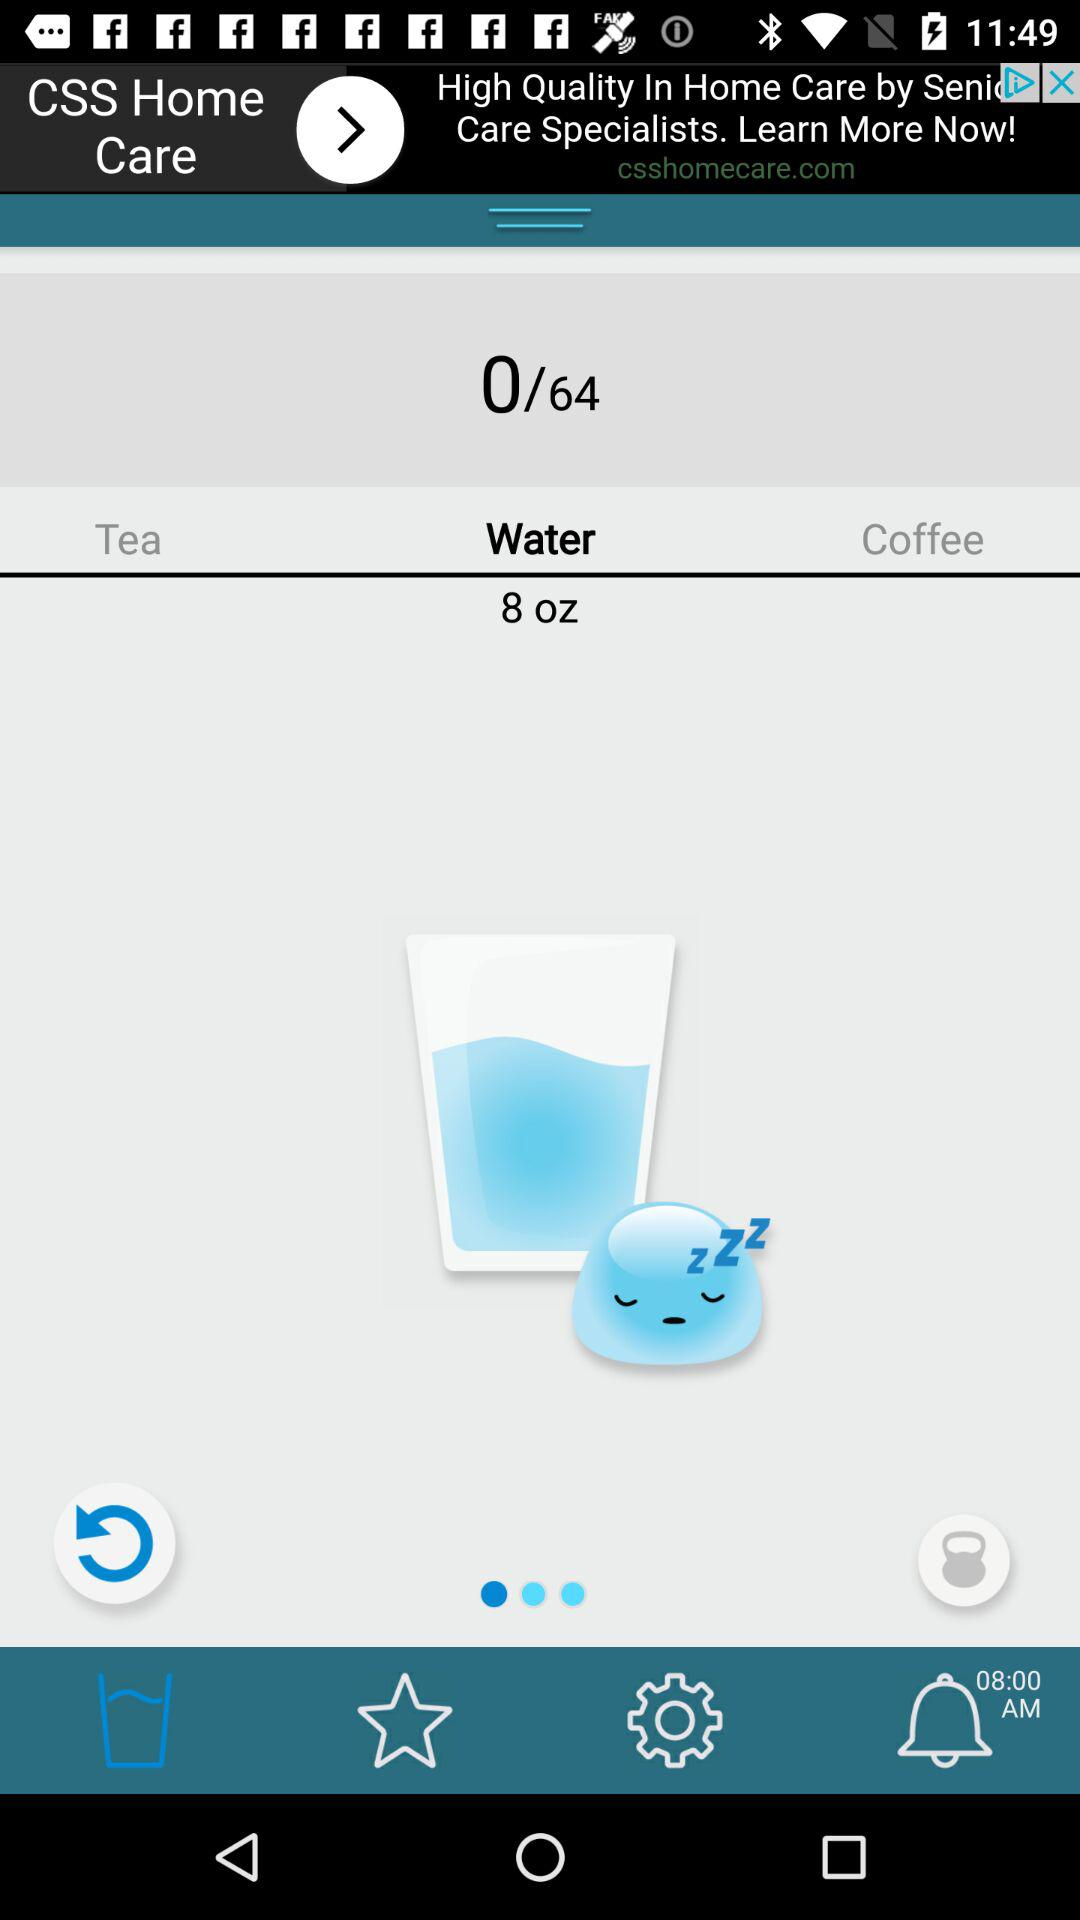For what time is the alarm set? The alarm is set for 8 AM. 